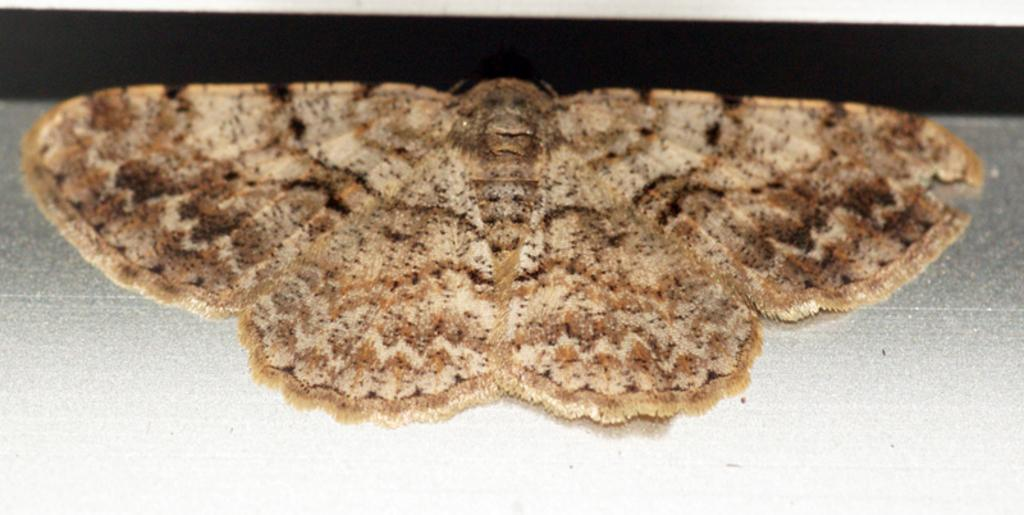What type of insect is present in the image? There is a brown house moth in the image. What type of company is depicted in the image? There is no company depicted in the image; it features a brown house moth. What type of paste is being used by the hand in the image? There is no hand or paste present in the image; it only features a brown house moth. 